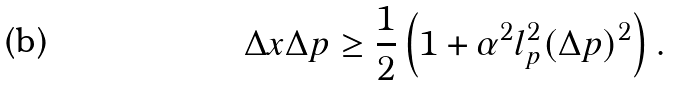Convert formula to latex. <formula><loc_0><loc_0><loc_500><loc_500>\Delta x \Delta p \geq \frac { 1 } { 2 } \left ( 1 + \alpha ^ { 2 } l _ { p } ^ { 2 } ( \Delta p ) ^ { 2 } \right ) .</formula> 